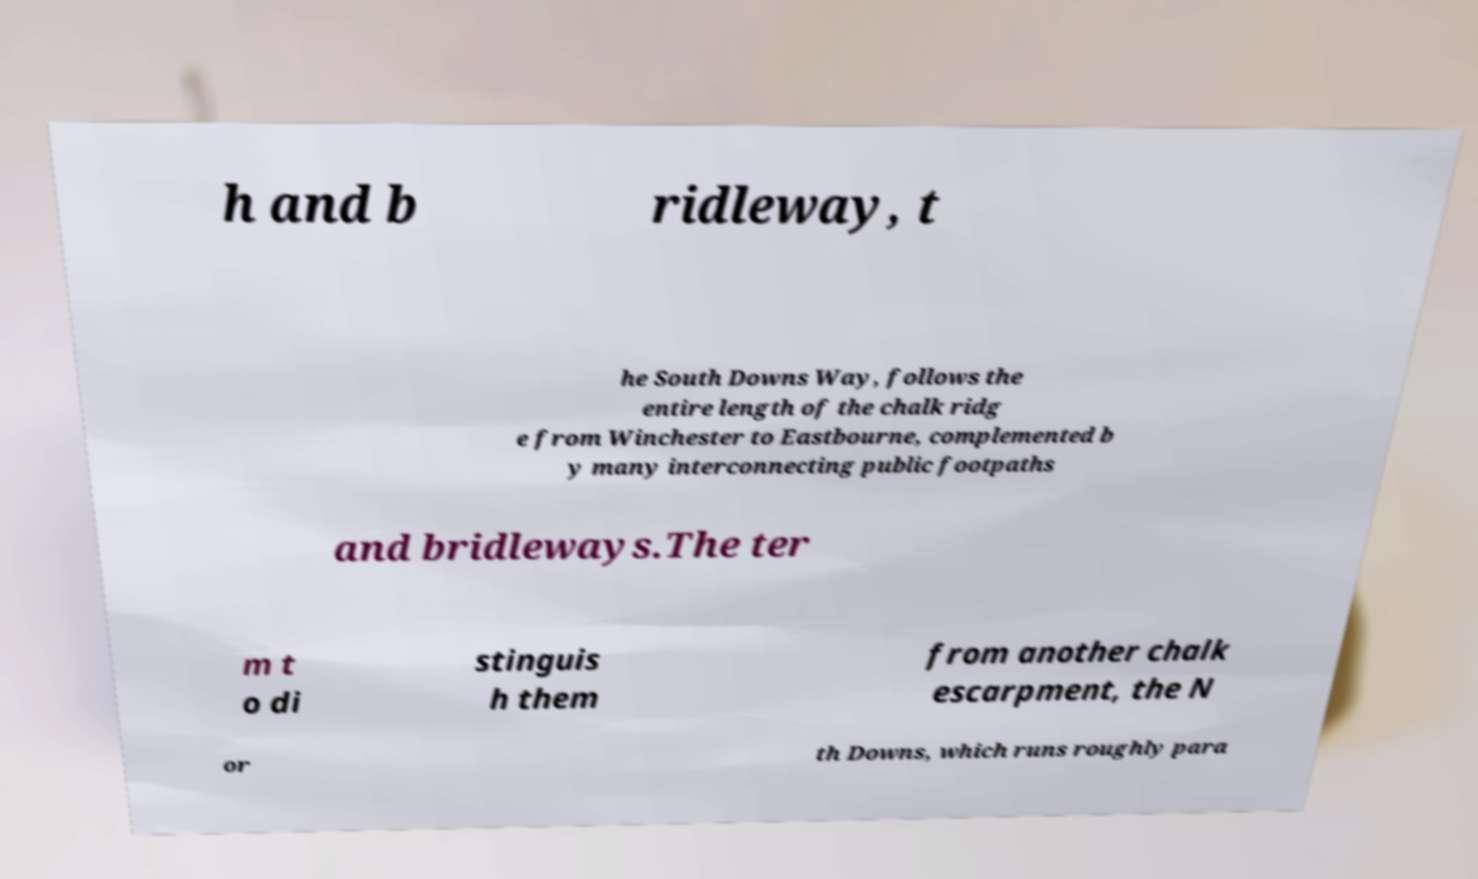Can you accurately transcribe the text from the provided image for me? h and b ridleway, t he South Downs Way, follows the entire length of the chalk ridg e from Winchester to Eastbourne, complemented b y many interconnecting public footpaths and bridleways.The ter m t o di stinguis h them from another chalk escarpment, the N or th Downs, which runs roughly para 